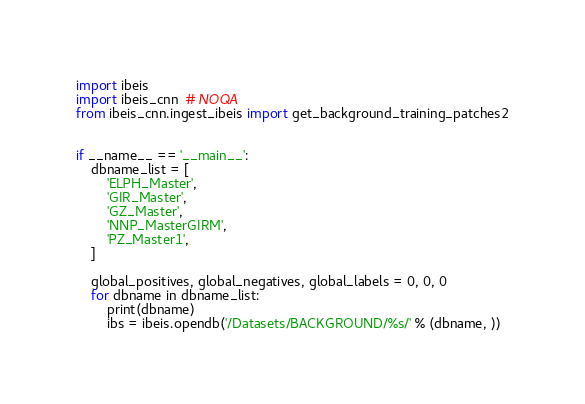<code> <loc_0><loc_0><loc_500><loc_500><_Python_>import ibeis
import ibeis_cnn  # NOQA
from ibeis_cnn.ingest_ibeis import get_background_training_patches2


if __name__ == '__main__':
    dbname_list = [
        'ELPH_Master',
        'GIR_Master',
        'GZ_Master',
        'NNP_MasterGIRM',
        'PZ_Master1',
    ]

    global_positives, global_negatives, global_labels = 0, 0, 0
    for dbname in dbname_list:
        print(dbname)
        ibs = ibeis.opendb('/Datasets/BACKGROUND/%s/' % (dbname, ))</code> 